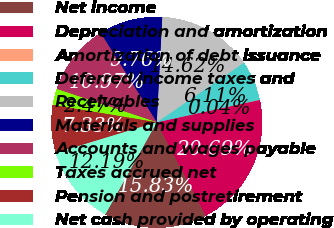Convert chart to OTSL. <chart><loc_0><loc_0><loc_500><loc_500><pie_chart><fcel>Net income<fcel>Depreciation and amortization<fcel>Amortization of debt issuance<fcel>Deferred income taxes and<fcel>Receivables<fcel>Materials and supplies<fcel>Accounts and wages payable<fcel>Taxes accrued net<fcel>Pension and postretirement<fcel>Net cash provided by operating<nl><fcel>15.83%<fcel>20.69%<fcel>0.04%<fcel>6.11%<fcel>14.62%<fcel>9.76%<fcel>10.97%<fcel>2.47%<fcel>7.33%<fcel>12.19%<nl></chart> 